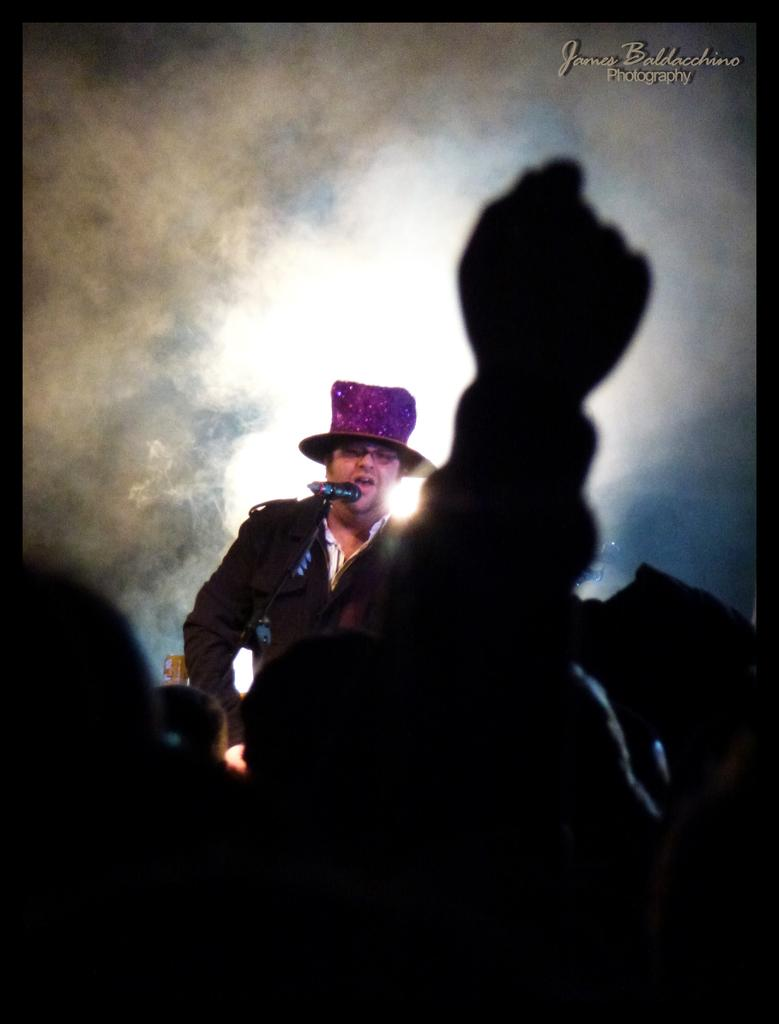What can be seen in the front of the image? There are persons in the front of the image. What is happening in the background of the image? There is a man standing in the background of the image. What is the man doing? The man is singing. What is the man wearing on his head? The man is wearing a pink-colored hat. How many cows are present in the image? There are no cows present in the image. What type of dolls can be seen in the image? There are no dolls present in the image. 